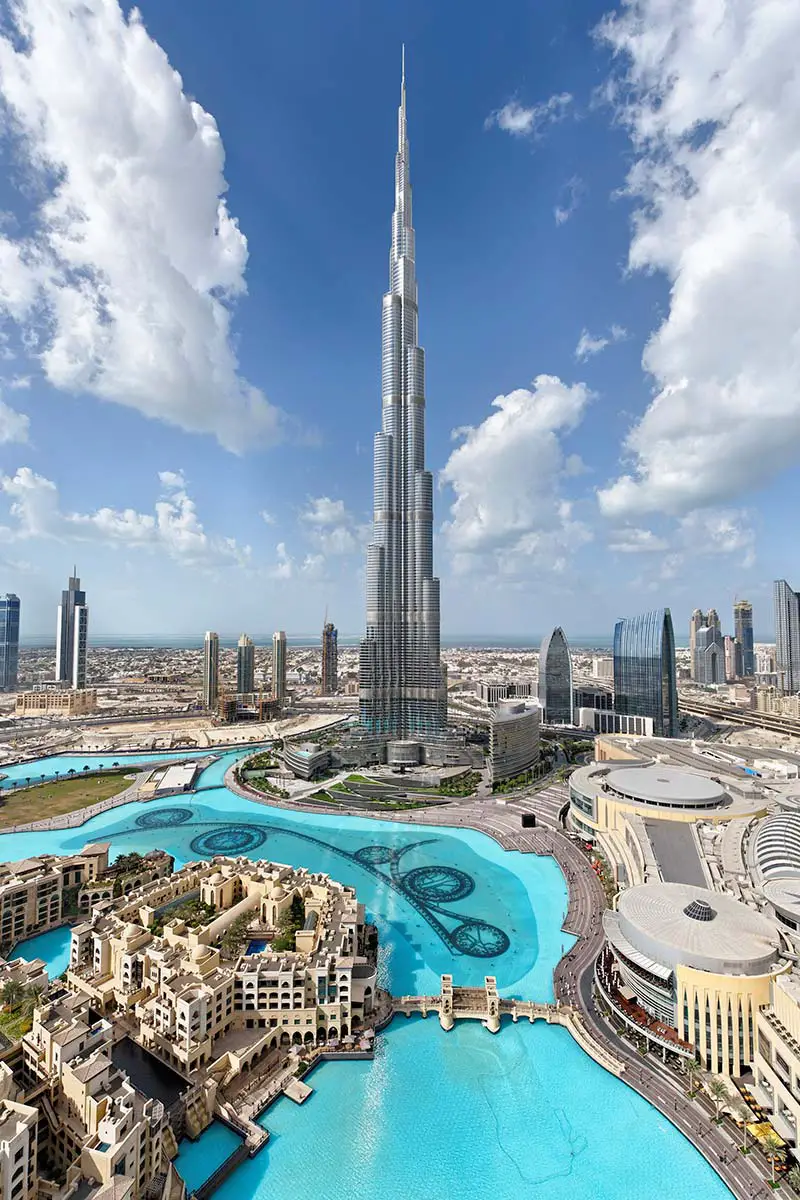Can you tell a story inspired by this image? In the heart of Dubai, amidst the towering skyscrapers and intricate roadways, a young architect named Amina stood gazing up at the Burj Khalifa. It had been her lifelong dream to design something that could stand proudly next to this majestic marvel. Every day at dawn, she'd take her sketchbook to the blue-green waters beside the towering giant, sketching and dreaming. One day, inspired by the seamless blend of modernity and nature she observed, she conceptualized a revolutionary new eco-friendly skyscraper. Her design quickly gained traction, and in the shadow of the Burj Khalifa, a new symbol of sustainable innovation began to rise, heralding a new era of architectural brilliance in Dubai. 